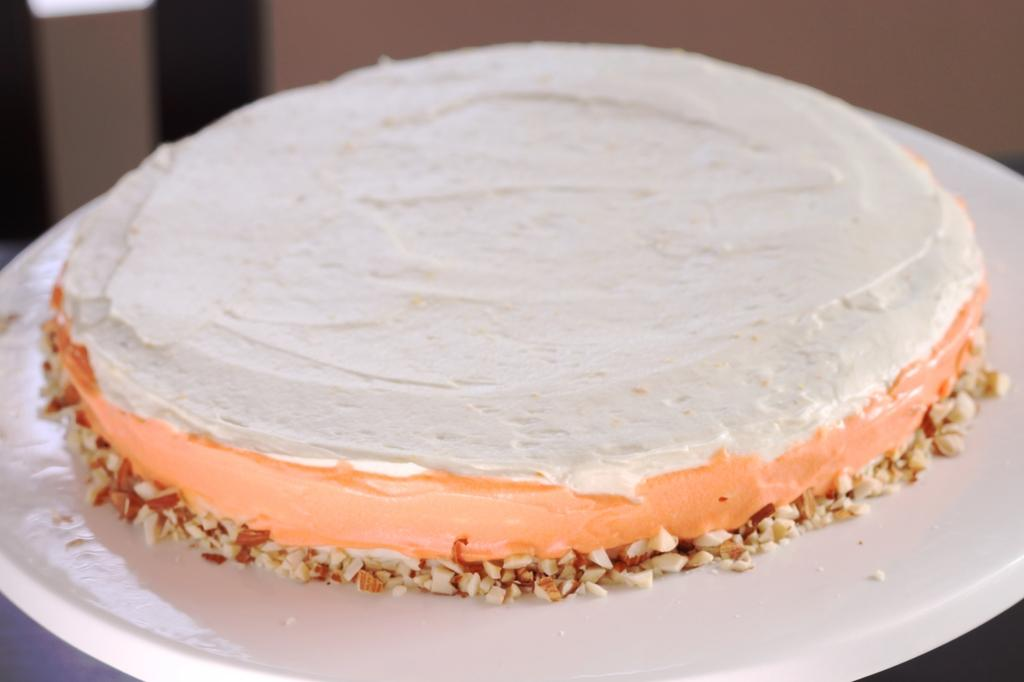What is the main subject of the image? The main subject of the image is a cake. Where is the cake located in the image? The cake is on a cake stand. What is the purpose of the dogs in the image? There are no dogs present in the image, so there is no purpose for them. What type of basin can be seen in the image? There is no basin present in the image. 